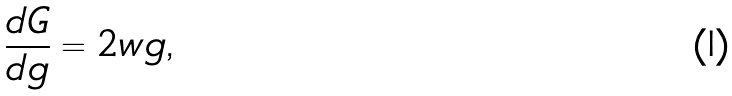Convert formula to latex. <formula><loc_0><loc_0><loc_500><loc_500>\frac { d G } { d g } = 2 w g \text {,}</formula> 